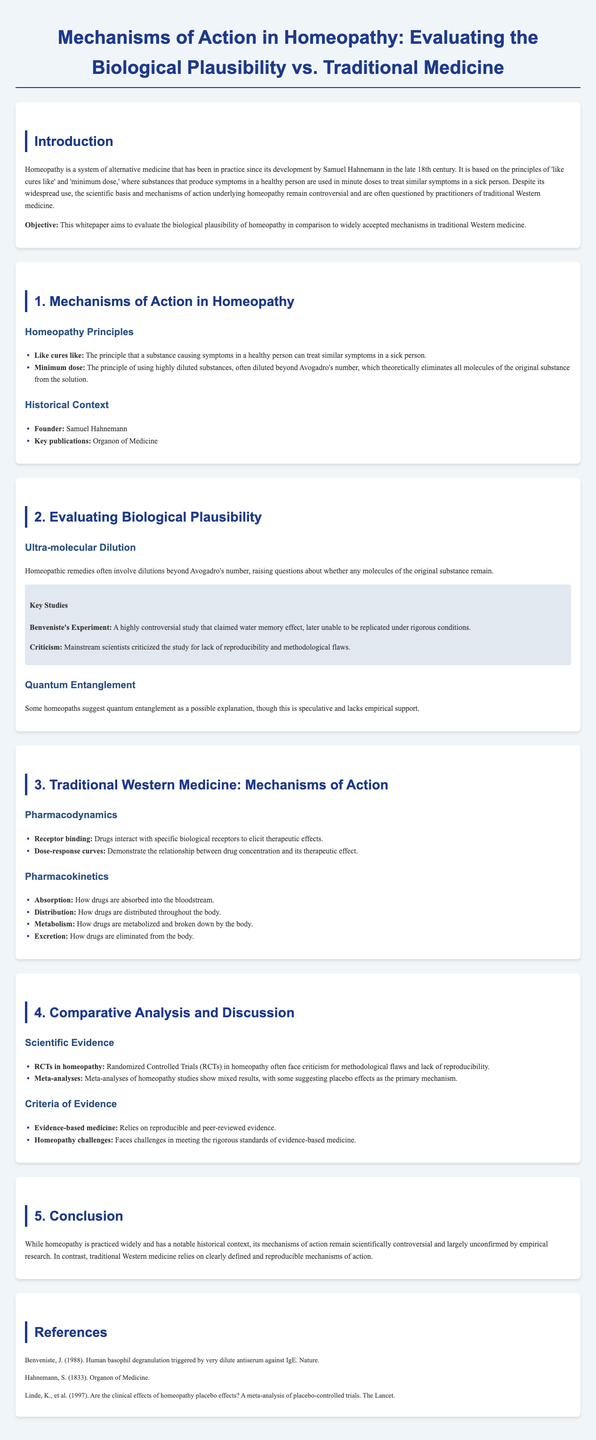what is the system of alternative medicine discussed in the paper? The paper discusses homeopathy as a system of alternative medicine developed by Samuel Hahnemann.
Answer: homeopathy who is the founder of homeopathy? The document states that Samuel Hahnemann is the founder of homeopathy.
Answer: Samuel Hahnemann what principle suggests that a substance causing symptoms can treat similar symptoms? The principle referred to is "like cures like."
Answer: like cures like what is the key publication of homeopathy mentioned in the paper? The key publication mentioned is the "Organon of Medicine."
Answer: Organon of Medicine what was the name of the controversial study related to homeopathy? The controversial study is known as Benveniste's Experiment.
Answer: Benveniste's Experiment what is the primary criticism of randomized controlled trials in homeopathy? RCTs in homeopathy face criticism for methodological flaws and lack of reproducibility.
Answer: methodological flaws and lack of reproducibility which concept is mentioned as a potential explanation for homeopathy but lacks empirical support? The concept mentioned is quantum entanglement.
Answer: quantum entanglement what does the conclusion state about homeopathy's mechanisms of action? The conclusion states that homeopathy's mechanisms of action remain scientifically controversial and largely unconfirmed.
Answer: scientifically controversial and largely unconfirmed what do homeopathy studies often suggest as the primary mechanism of effect? Homeopathy studies often suggest placebo effects as the primary mechanism.
Answer: placebo effects 